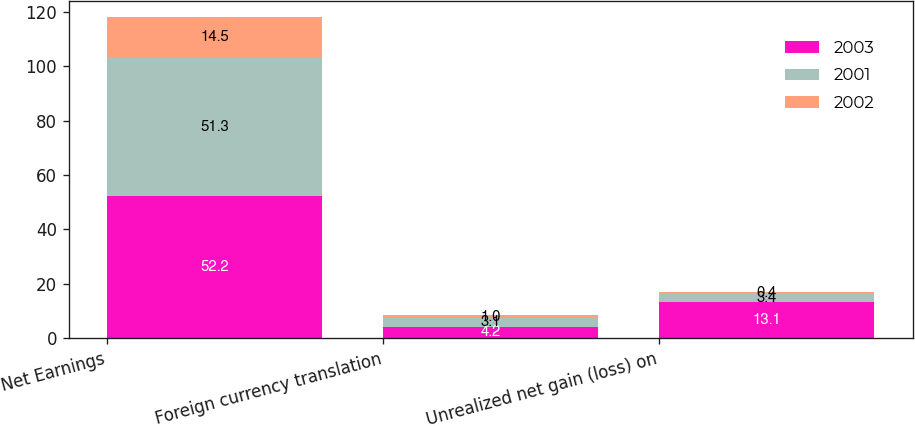Convert chart. <chart><loc_0><loc_0><loc_500><loc_500><stacked_bar_chart><ecel><fcel>Net Earnings<fcel>Foreign currency translation<fcel>Unrealized net gain (loss) on<nl><fcel>2003<fcel>52.2<fcel>4.2<fcel>13.1<nl><fcel>2001<fcel>51.3<fcel>3.1<fcel>3.4<nl><fcel>2002<fcel>14.5<fcel>1<fcel>0.4<nl></chart> 